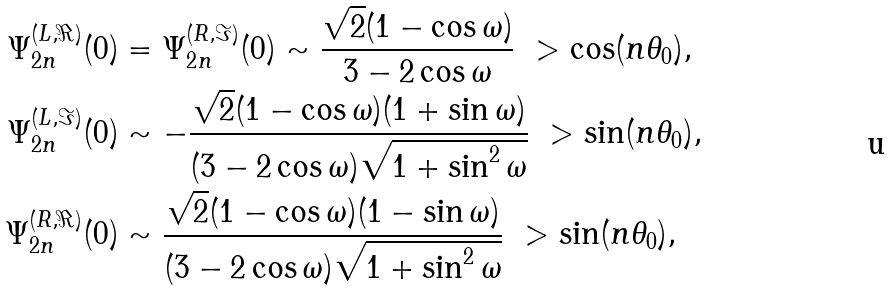Convert formula to latex. <formula><loc_0><loc_0><loc_500><loc_500>\Psi _ { 2 n } ^ { ( L , \Re ) } ( 0 ) & = \Psi _ { 2 n } ^ { ( R , \Im ) } ( 0 ) \sim \frac { \sqrt { 2 } ( 1 - \cos \omega ) } { 3 - 2 \cos \omega } \ > \cos ( n \theta _ { 0 } ) , \\ \Psi _ { 2 n } ^ { ( L , \Im ) } ( 0 ) & \sim - \frac { \sqrt { 2 } ( 1 - \cos \omega ) ( 1 + \sin \omega ) } { ( 3 - 2 \cos \omega ) \sqrt { 1 + \sin ^ { 2 } \omega } } \ > \sin ( n \theta _ { 0 } ) , \\ \Psi _ { 2 n } ^ { ( R , \Re ) } ( 0 ) & \sim \frac { \sqrt { 2 } ( 1 - \cos \omega ) ( 1 - \sin \omega ) } { ( 3 - 2 \cos \omega ) \sqrt { 1 + \sin ^ { 2 } \omega } } \ > \sin ( n \theta _ { 0 } ) ,</formula> 